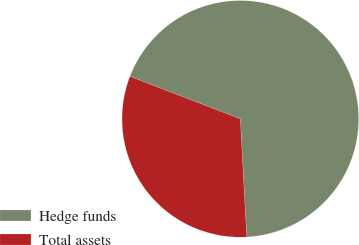<chart> <loc_0><loc_0><loc_500><loc_500><pie_chart><fcel>Hedge funds<fcel>Total assets<nl><fcel>68.29%<fcel>31.71%<nl></chart> 